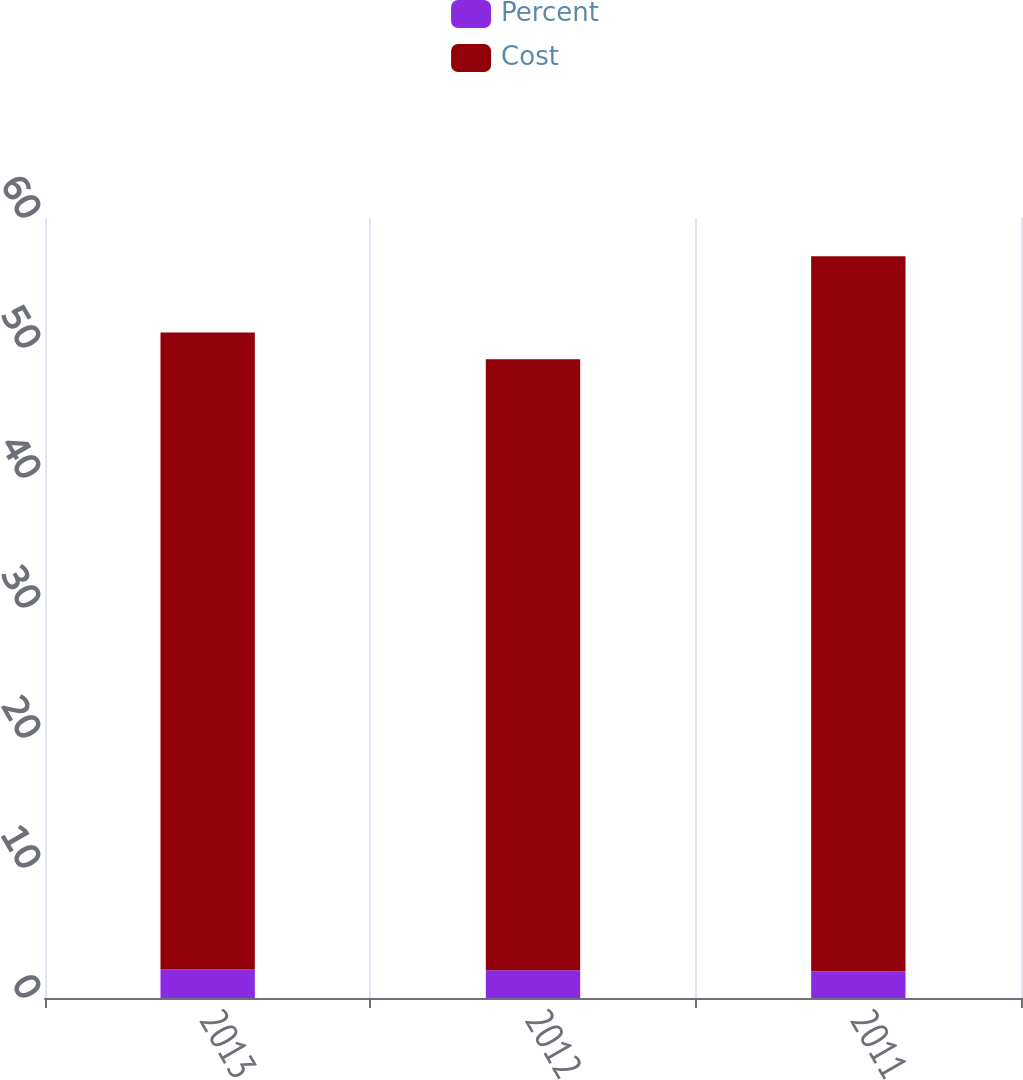Convert chart. <chart><loc_0><loc_0><loc_500><loc_500><stacked_bar_chart><ecel><fcel>2013<fcel>2012<fcel>2011<nl><fcel>Percent<fcel>2.2<fcel>2.13<fcel>2.06<nl><fcel>Cost<fcel>49<fcel>47<fcel>55<nl></chart> 